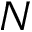Convert formula to latex. <formula><loc_0><loc_0><loc_500><loc_500>N</formula> 